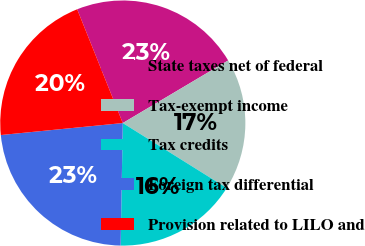Convert chart. <chart><loc_0><loc_0><loc_500><loc_500><pie_chart><fcel>State taxes net of federal<fcel>Tax-exempt income<fcel>Tax credits<fcel>Foreign tax differential<fcel>Provision related to LILO and<nl><fcel>22.54%<fcel>17.42%<fcel>16.39%<fcel>23.16%<fcel>20.49%<nl></chart> 